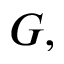Convert formula to latex. <formula><loc_0><loc_0><loc_500><loc_500>G ,</formula> 